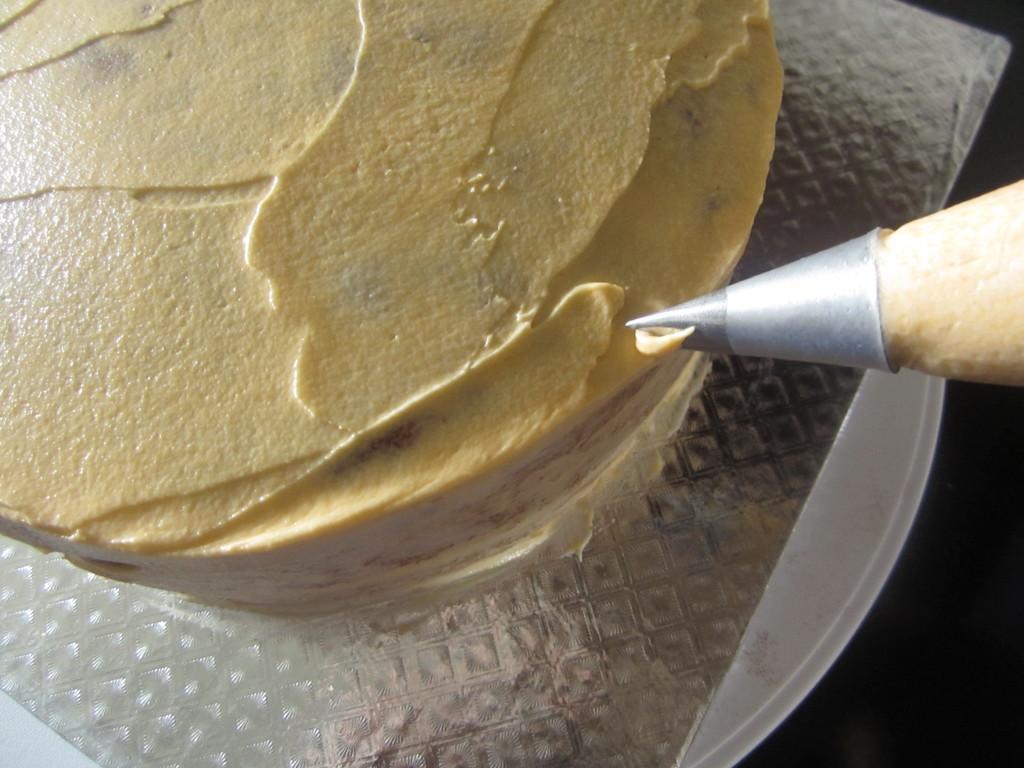Please provide a concise description of this image. In this image there is a cake, icing cone, cardboard and plate. 